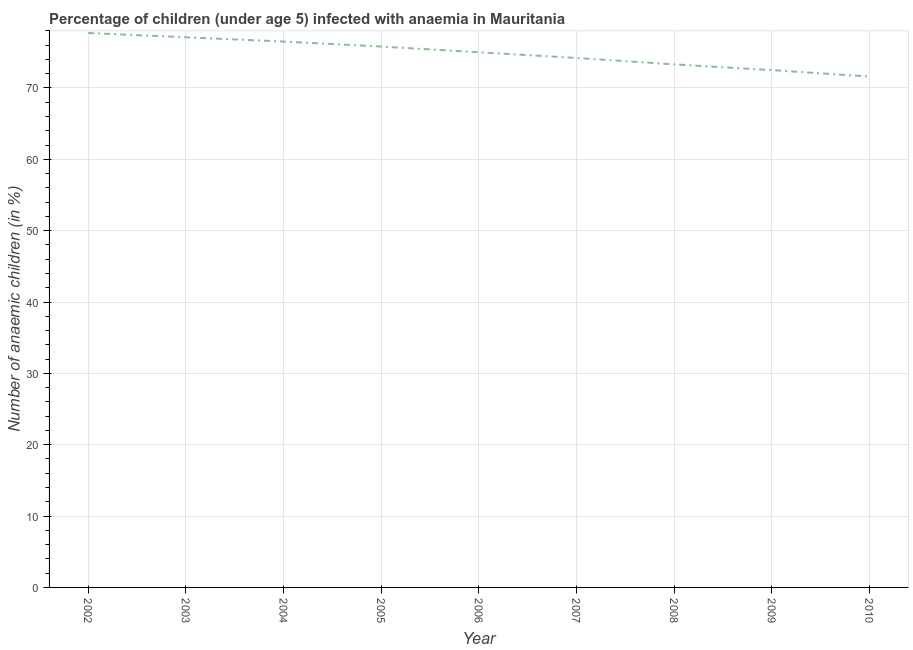What is the number of anaemic children in 2002?
Give a very brief answer. 77.7. Across all years, what is the maximum number of anaemic children?
Provide a succinct answer. 77.7. Across all years, what is the minimum number of anaemic children?
Provide a short and direct response. 71.6. What is the sum of the number of anaemic children?
Keep it short and to the point. 673.7. What is the difference between the number of anaemic children in 2002 and 2003?
Provide a succinct answer. 0.6. What is the average number of anaemic children per year?
Provide a short and direct response. 74.86. What is the median number of anaemic children?
Provide a short and direct response. 75. What is the ratio of the number of anaemic children in 2003 to that in 2004?
Your answer should be compact. 1.01. What is the difference between the highest and the second highest number of anaemic children?
Keep it short and to the point. 0.6. What is the difference between the highest and the lowest number of anaemic children?
Your answer should be compact. 6.1. How many lines are there?
Provide a short and direct response. 1. Are the values on the major ticks of Y-axis written in scientific E-notation?
Your response must be concise. No. What is the title of the graph?
Make the answer very short. Percentage of children (under age 5) infected with anaemia in Mauritania. What is the label or title of the Y-axis?
Provide a succinct answer. Number of anaemic children (in %). What is the Number of anaemic children (in %) of 2002?
Make the answer very short. 77.7. What is the Number of anaemic children (in %) in 2003?
Your answer should be compact. 77.1. What is the Number of anaemic children (in %) in 2004?
Give a very brief answer. 76.5. What is the Number of anaemic children (in %) in 2005?
Make the answer very short. 75.8. What is the Number of anaemic children (in %) in 2007?
Provide a succinct answer. 74.2. What is the Number of anaemic children (in %) in 2008?
Offer a terse response. 73.3. What is the Number of anaemic children (in %) in 2009?
Provide a succinct answer. 72.5. What is the Number of anaemic children (in %) of 2010?
Keep it short and to the point. 71.6. What is the difference between the Number of anaemic children (in %) in 2002 and 2004?
Your answer should be very brief. 1.2. What is the difference between the Number of anaemic children (in %) in 2002 and 2007?
Provide a succinct answer. 3.5. What is the difference between the Number of anaemic children (in %) in 2002 and 2009?
Provide a short and direct response. 5.2. What is the difference between the Number of anaemic children (in %) in 2002 and 2010?
Make the answer very short. 6.1. What is the difference between the Number of anaemic children (in %) in 2003 and 2004?
Ensure brevity in your answer.  0.6. What is the difference between the Number of anaemic children (in %) in 2003 and 2009?
Give a very brief answer. 4.6. What is the difference between the Number of anaemic children (in %) in 2003 and 2010?
Ensure brevity in your answer.  5.5. What is the difference between the Number of anaemic children (in %) in 2004 and 2005?
Keep it short and to the point. 0.7. What is the difference between the Number of anaemic children (in %) in 2004 and 2009?
Offer a terse response. 4. What is the difference between the Number of anaemic children (in %) in 2005 and 2009?
Make the answer very short. 3.3. What is the difference between the Number of anaemic children (in %) in 2006 and 2009?
Provide a succinct answer. 2.5. What is the difference between the Number of anaemic children (in %) in 2007 and 2008?
Your answer should be compact. 0.9. What is the difference between the Number of anaemic children (in %) in 2008 and 2010?
Provide a short and direct response. 1.7. What is the ratio of the Number of anaemic children (in %) in 2002 to that in 2004?
Your response must be concise. 1.02. What is the ratio of the Number of anaemic children (in %) in 2002 to that in 2005?
Keep it short and to the point. 1.02. What is the ratio of the Number of anaemic children (in %) in 2002 to that in 2006?
Give a very brief answer. 1.04. What is the ratio of the Number of anaemic children (in %) in 2002 to that in 2007?
Your answer should be compact. 1.05. What is the ratio of the Number of anaemic children (in %) in 2002 to that in 2008?
Provide a short and direct response. 1.06. What is the ratio of the Number of anaemic children (in %) in 2002 to that in 2009?
Give a very brief answer. 1.07. What is the ratio of the Number of anaemic children (in %) in 2002 to that in 2010?
Keep it short and to the point. 1.08. What is the ratio of the Number of anaemic children (in %) in 2003 to that in 2004?
Your answer should be very brief. 1.01. What is the ratio of the Number of anaemic children (in %) in 2003 to that in 2005?
Offer a terse response. 1.02. What is the ratio of the Number of anaemic children (in %) in 2003 to that in 2006?
Provide a short and direct response. 1.03. What is the ratio of the Number of anaemic children (in %) in 2003 to that in 2007?
Your answer should be compact. 1.04. What is the ratio of the Number of anaemic children (in %) in 2003 to that in 2008?
Your response must be concise. 1.05. What is the ratio of the Number of anaemic children (in %) in 2003 to that in 2009?
Give a very brief answer. 1.06. What is the ratio of the Number of anaemic children (in %) in 2003 to that in 2010?
Offer a very short reply. 1.08. What is the ratio of the Number of anaemic children (in %) in 2004 to that in 2005?
Offer a terse response. 1.01. What is the ratio of the Number of anaemic children (in %) in 2004 to that in 2006?
Your response must be concise. 1.02. What is the ratio of the Number of anaemic children (in %) in 2004 to that in 2007?
Your response must be concise. 1.03. What is the ratio of the Number of anaemic children (in %) in 2004 to that in 2008?
Ensure brevity in your answer.  1.04. What is the ratio of the Number of anaemic children (in %) in 2004 to that in 2009?
Provide a short and direct response. 1.05. What is the ratio of the Number of anaemic children (in %) in 2004 to that in 2010?
Give a very brief answer. 1.07. What is the ratio of the Number of anaemic children (in %) in 2005 to that in 2006?
Make the answer very short. 1.01. What is the ratio of the Number of anaemic children (in %) in 2005 to that in 2008?
Make the answer very short. 1.03. What is the ratio of the Number of anaemic children (in %) in 2005 to that in 2009?
Your answer should be compact. 1.05. What is the ratio of the Number of anaemic children (in %) in 2005 to that in 2010?
Your response must be concise. 1.06. What is the ratio of the Number of anaemic children (in %) in 2006 to that in 2007?
Your answer should be very brief. 1.01. What is the ratio of the Number of anaemic children (in %) in 2006 to that in 2008?
Ensure brevity in your answer.  1.02. What is the ratio of the Number of anaemic children (in %) in 2006 to that in 2009?
Offer a terse response. 1.03. What is the ratio of the Number of anaemic children (in %) in 2006 to that in 2010?
Your answer should be very brief. 1.05. What is the ratio of the Number of anaemic children (in %) in 2007 to that in 2008?
Your answer should be compact. 1.01. What is the ratio of the Number of anaemic children (in %) in 2007 to that in 2010?
Your answer should be very brief. 1.04. What is the ratio of the Number of anaemic children (in %) in 2008 to that in 2009?
Ensure brevity in your answer.  1.01. What is the ratio of the Number of anaemic children (in %) in 2009 to that in 2010?
Make the answer very short. 1.01. 